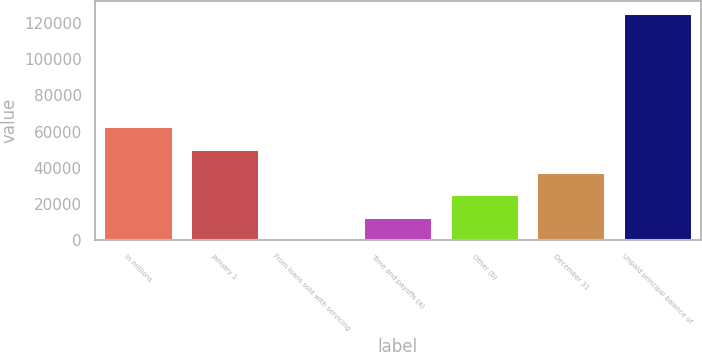<chart> <loc_0><loc_0><loc_500><loc_500><bar_chart><fcel>In millions<fcel>January 1<fcel>From loans sold with servicing<fcel>Time and payoffs (a)<fcel>Other (b)<fcel>December 31<fcel>Unpaid principal balance of<nl><fcel>62950.5<fcel>50379.4<fcel>95<fcel>12666.1<fcel>25237.2<fcel>37808.3<fcel>125806<nl></chart> 